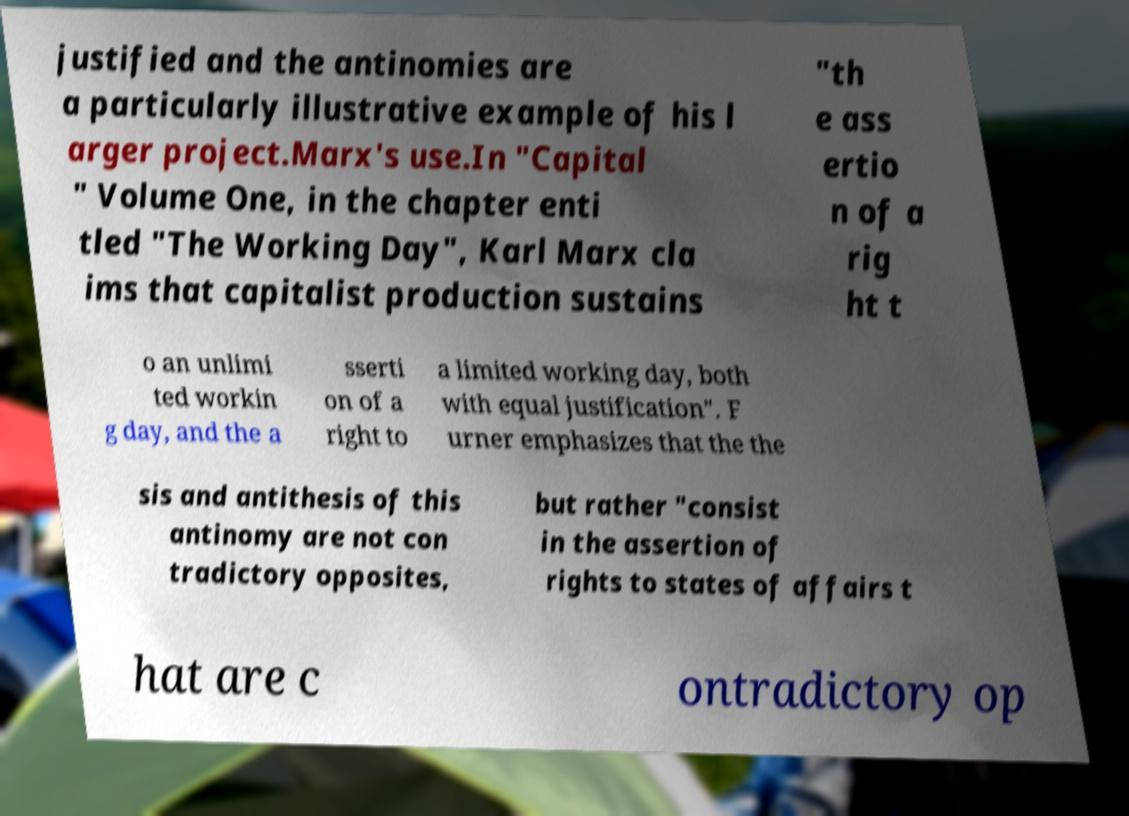Please identify and transcribe the text found in this image. justified and the antinomies are a particularly illustrative example of his l arger project.Marx's use.In "Capital " Volume One, in the chapter enti tled "The Working Day", Karl Marx cla ims that capitalist production sustains "th e ass ertio n of a rig ht t o an unlimi ted workin g day, and the a sserti on of a right to a limited working day, both with equal justification". F urner emphasizes that the the sis and antithesis of this antinomy are not con tradictory opposites, but rather "consist in the assertion of rights to states of affairs t hat are c ontradictory op 